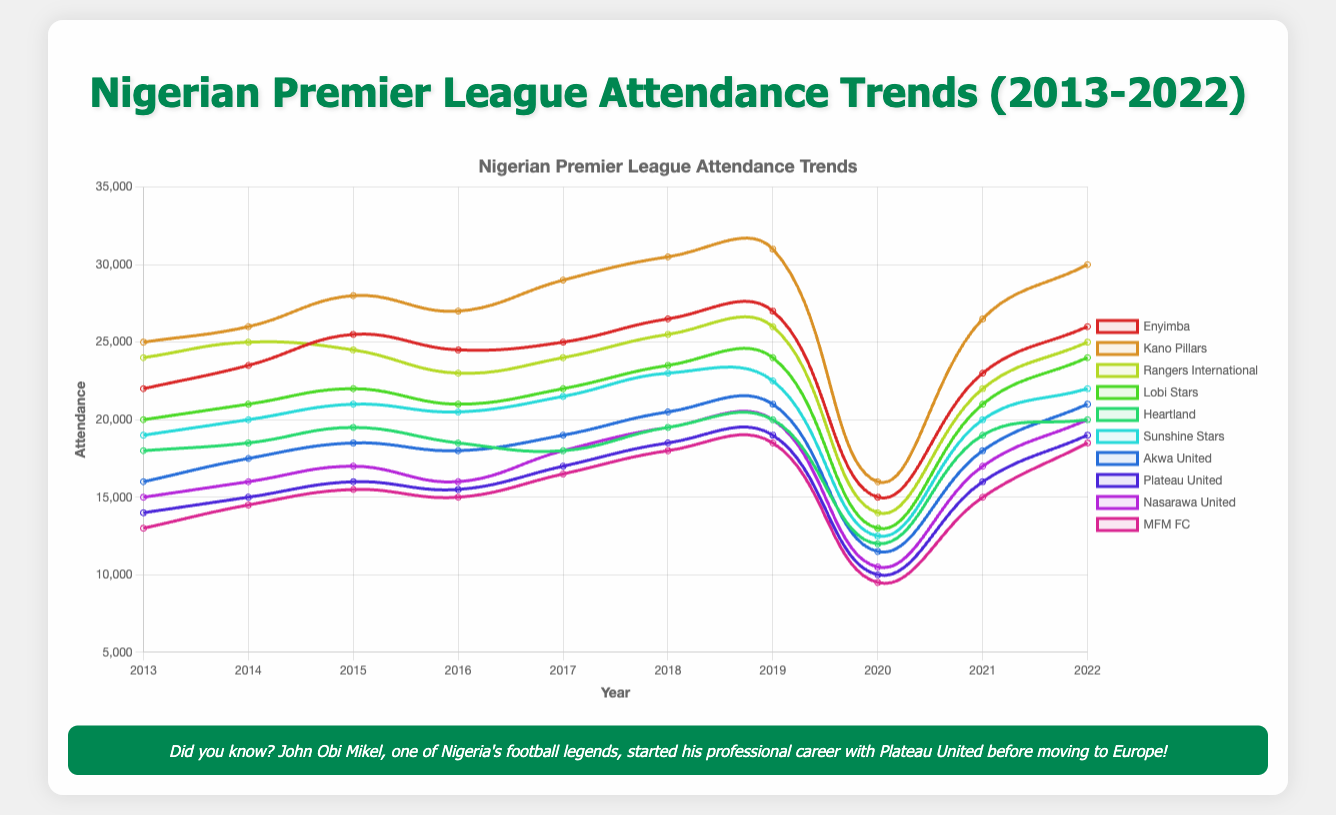Which team had the highest average attendance over the decade? To find the highest average attendance, calculate the average attendance for each team and compare them: Enyimba (23700), Kano Pillars (26950), Rangers International (22950), Lobi Stars (21500), Heartland (18300), Sunshine Stars (20150), Akwa United (18000), Plateau United (16000), Nasarawa United (17100), MFM FC (15000). Kano Pillars has the highest average
Answer: Kano Pillars In which year did Plateau United have the lowest attendance? Examine the attendance data of Plateau United across the years to find the lowest value, which is 10000 in 2020
Answer: 2020 Which teams had a noticeable drop in attendance in 2020 compared to 2019? To identify teams with a noticeable drop, compare the attendances of 2019 and 2020 for each team: Enyimba (27000 to 15000), Kano Pillars (31000 to 16000), Rangers International (26000 to 14000), Lobi Stars (24000 to 13000), Heartland (20000 to 12000), Sunshine Stars (22500 to 12500), Akwa United (21000 to 11500), Plateau United (19000 to 10000), Nasarawa United (20000 to 10500), MFM FC (18500 to 9500). All teams experienced a drop in 2020
Answer: All teams Between 2017 and 2018, which team saw the largest increase in attendance? Compare the attendance for each team between 2017 and 2018, and find the largest increase: Enyimba (25000 to 26500, increase of 1500), Kano Pillars (29000 to 30500, increase of 1500), Rangers International (24000 to 25500, increase of 1500), Lobi Stars (22000 to 23500, increase of 1500), Heartland (18000 to 19500, increase of 1500), Sunshine Stars (21500 to 23000, increase of 1500), Akwa United (19000 to 20500, increase of 1500), Plateau United (17000 to 18500, increase of 1500), Nasarawa United (18000 to 19500, increase of 1500), MFM FC (16500 to 18000, increase of 1500). All teams had the same increase of 1500
Answer: All teams sama increase How did the attendance of Enyimba in 2020 compare to its attendance in 2019? Compare Enyimba's attendance in 2020 (15000) to its attendance in 2019 (27000). The attendance in 2020 was significantly lower than in 2019
Answer: Lower What was the attendance difference between Kano Pillars and Heartland in 2022? Calculate the difference in attendance between Kano Pillars (30000) and Heartland (20000) in 2022, which is 10000
Answer: 10000 What's the sum of the attendances for Sunshine Stars over the decade? Add the attendances for Sunshine Stars from 2013 to 2022: 19000 + 20000 + 21000 + 20500 + 21500 + 23000 + 22500 + 12500 + 20000 + 22000 = 202000
Answer: 202000 In which year was the attendance of MFM FC closest to 15000? Compare the attendances of MFM FC and find the year closest to 15000: 13000 (2013), 14500 (2014), 15500 (2015), 15000 (2016). It is 15000 in 2016
Answer: 2016 Which team's attendance decreased the most between 2019 and 2020? Calculate the decrease in attendance for each team from 2019 to 2020: Enyimba (12000), Kano Pillars (15000), Rangers International (12000), Lobi Stars (11000), Heartland (8000), Sunshine Stars (10000), Akwa United (9500), Plateau United (9000), Nasarawa United (9500), MFM FC (9000). Kano Pillars had the largest decrease
Answer: Kano Pillars 